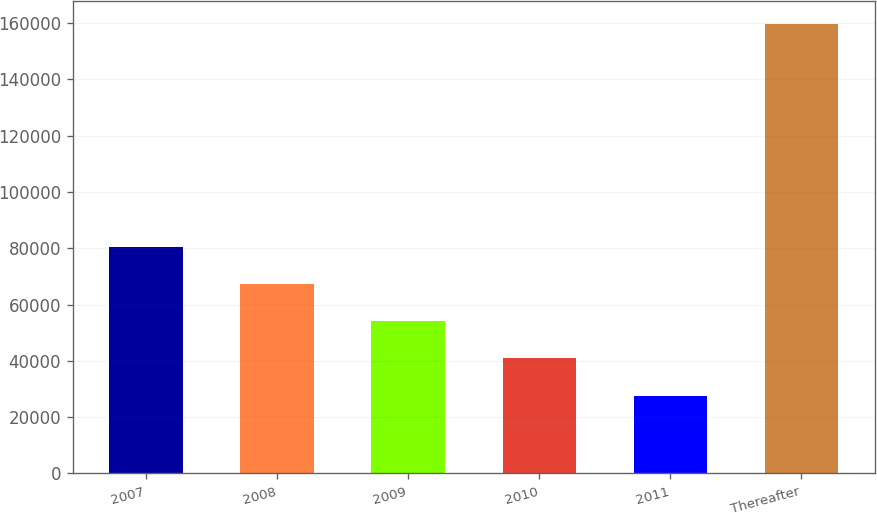Convert chart to OTSL. <chart><loc_0><loc_0><loc_500><loc_500><bar_chart><fcel>2007<fcel>2008<fcel>2009<fcel>2010<fcel>2011<fcel>Thereafter<nl><fcel>80461.8<fcel>67264.6<fcel>54067.4<fcel>40870.2<fcel>27673<fcel>159645<nl></chart> 